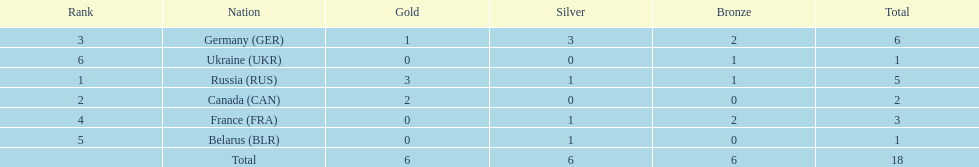Which country won more total medals than tue french, but less than the germans in the 1994 winter olympic biathlon? Russia. 